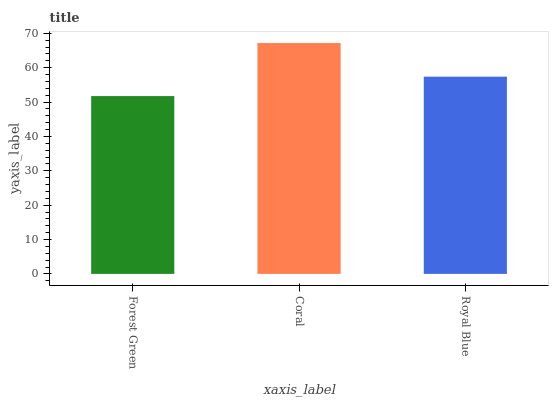Is Forest Green the minimum?
Answer yes or no. Yes. Is Coral the maximum?
Answer yes or no. Yes. Is Royal Blue the minimum?
Answer yes or no. No. Is Royal Blue the maximum?
Answer yes or no. No. Is Coral greater than Royal Blue?
Answer yes or no. Yes. Is Royal Blue less than Coral?
Answer yes or no. Yes. Is Royal Blue greater than Coral?
Answer yes or no. No. Is Coral less than Royal Blue?
Answer yes or no. No. Is Royal Blue the high median?
Answer yes or no. Yes. Is Royal Blue the low median?
Answer yes or no. Yes. Is Coral the high median?
Answer yes or no. No. Is Forest Green the low median?
Answer yes or no. No. 